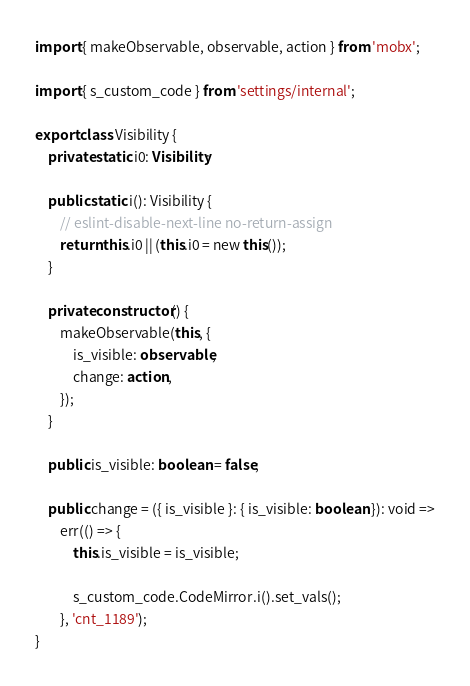<code> <loc_0><loc_0><loc_500><loc_500><_TypeScript_>import { makeObservable, observable, action } from 'mobx';

import { s_custom_code } from 'settings/internal';

export class Visibility {
    private static i0: Visibility;

    public static i(): Visibility {
        // eslint-disable-next-line no-return-assign
        return this.i0 || (this.i0 = new this());
    }

    private constructor() {
        makeObservable(this, {
            is_visible: observable,
            change: action,
        });
    }

    public is_visible: boolean = false;

    public change = ({ is_visible }: { is_visible: boolean }): void =>
        err(() => {
            this.is_visible = is_visible;

            s_custom_code.CodeMirror.i().set_vals();
        }, 'cnt_1189');
}
</code> 